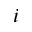Convert formula to latex. <formula><loc_0><loc_0><loc_500><loc_500>i</formula> 